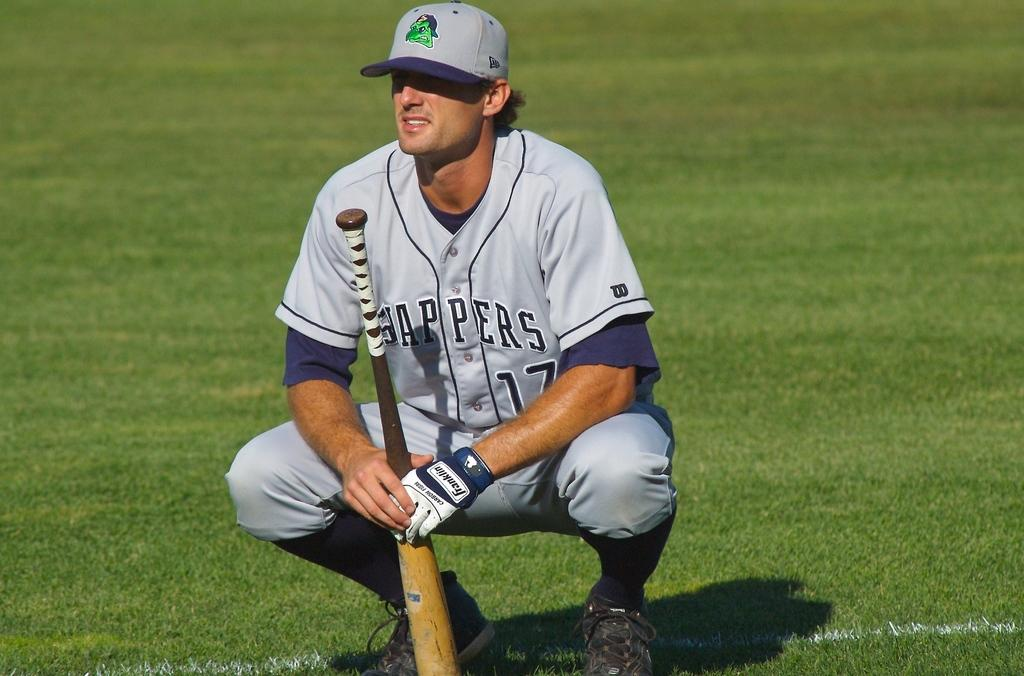<image>
Render a clear and concise summary of the photo. The Slappers player is holding a baseball bat. 